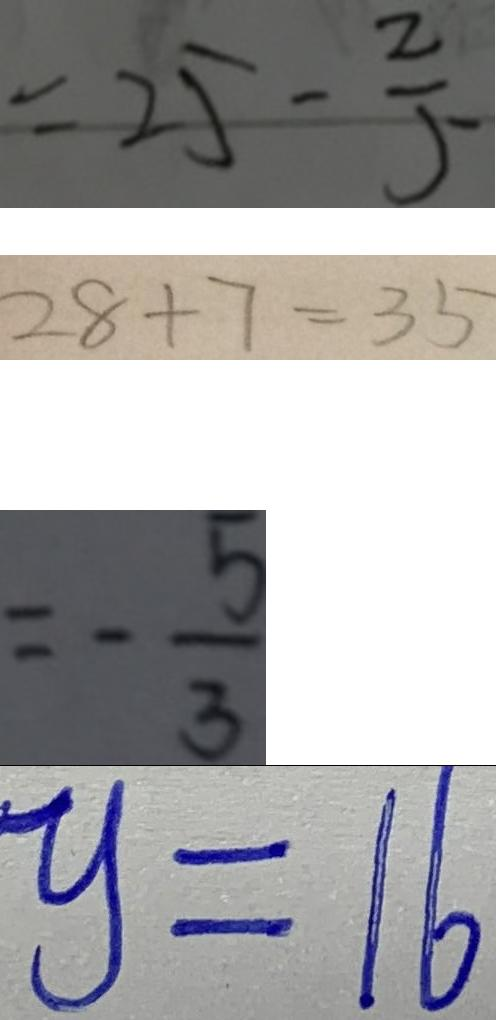<formula> <loc_0><loc_0><loc_500><loc_500>= 2 5 - \frac { 2 } { 5 } 
 2 8 + 7 = 3 5 
 = - \frac { 5 } { 3 } 
 y = 1 6</formula> 